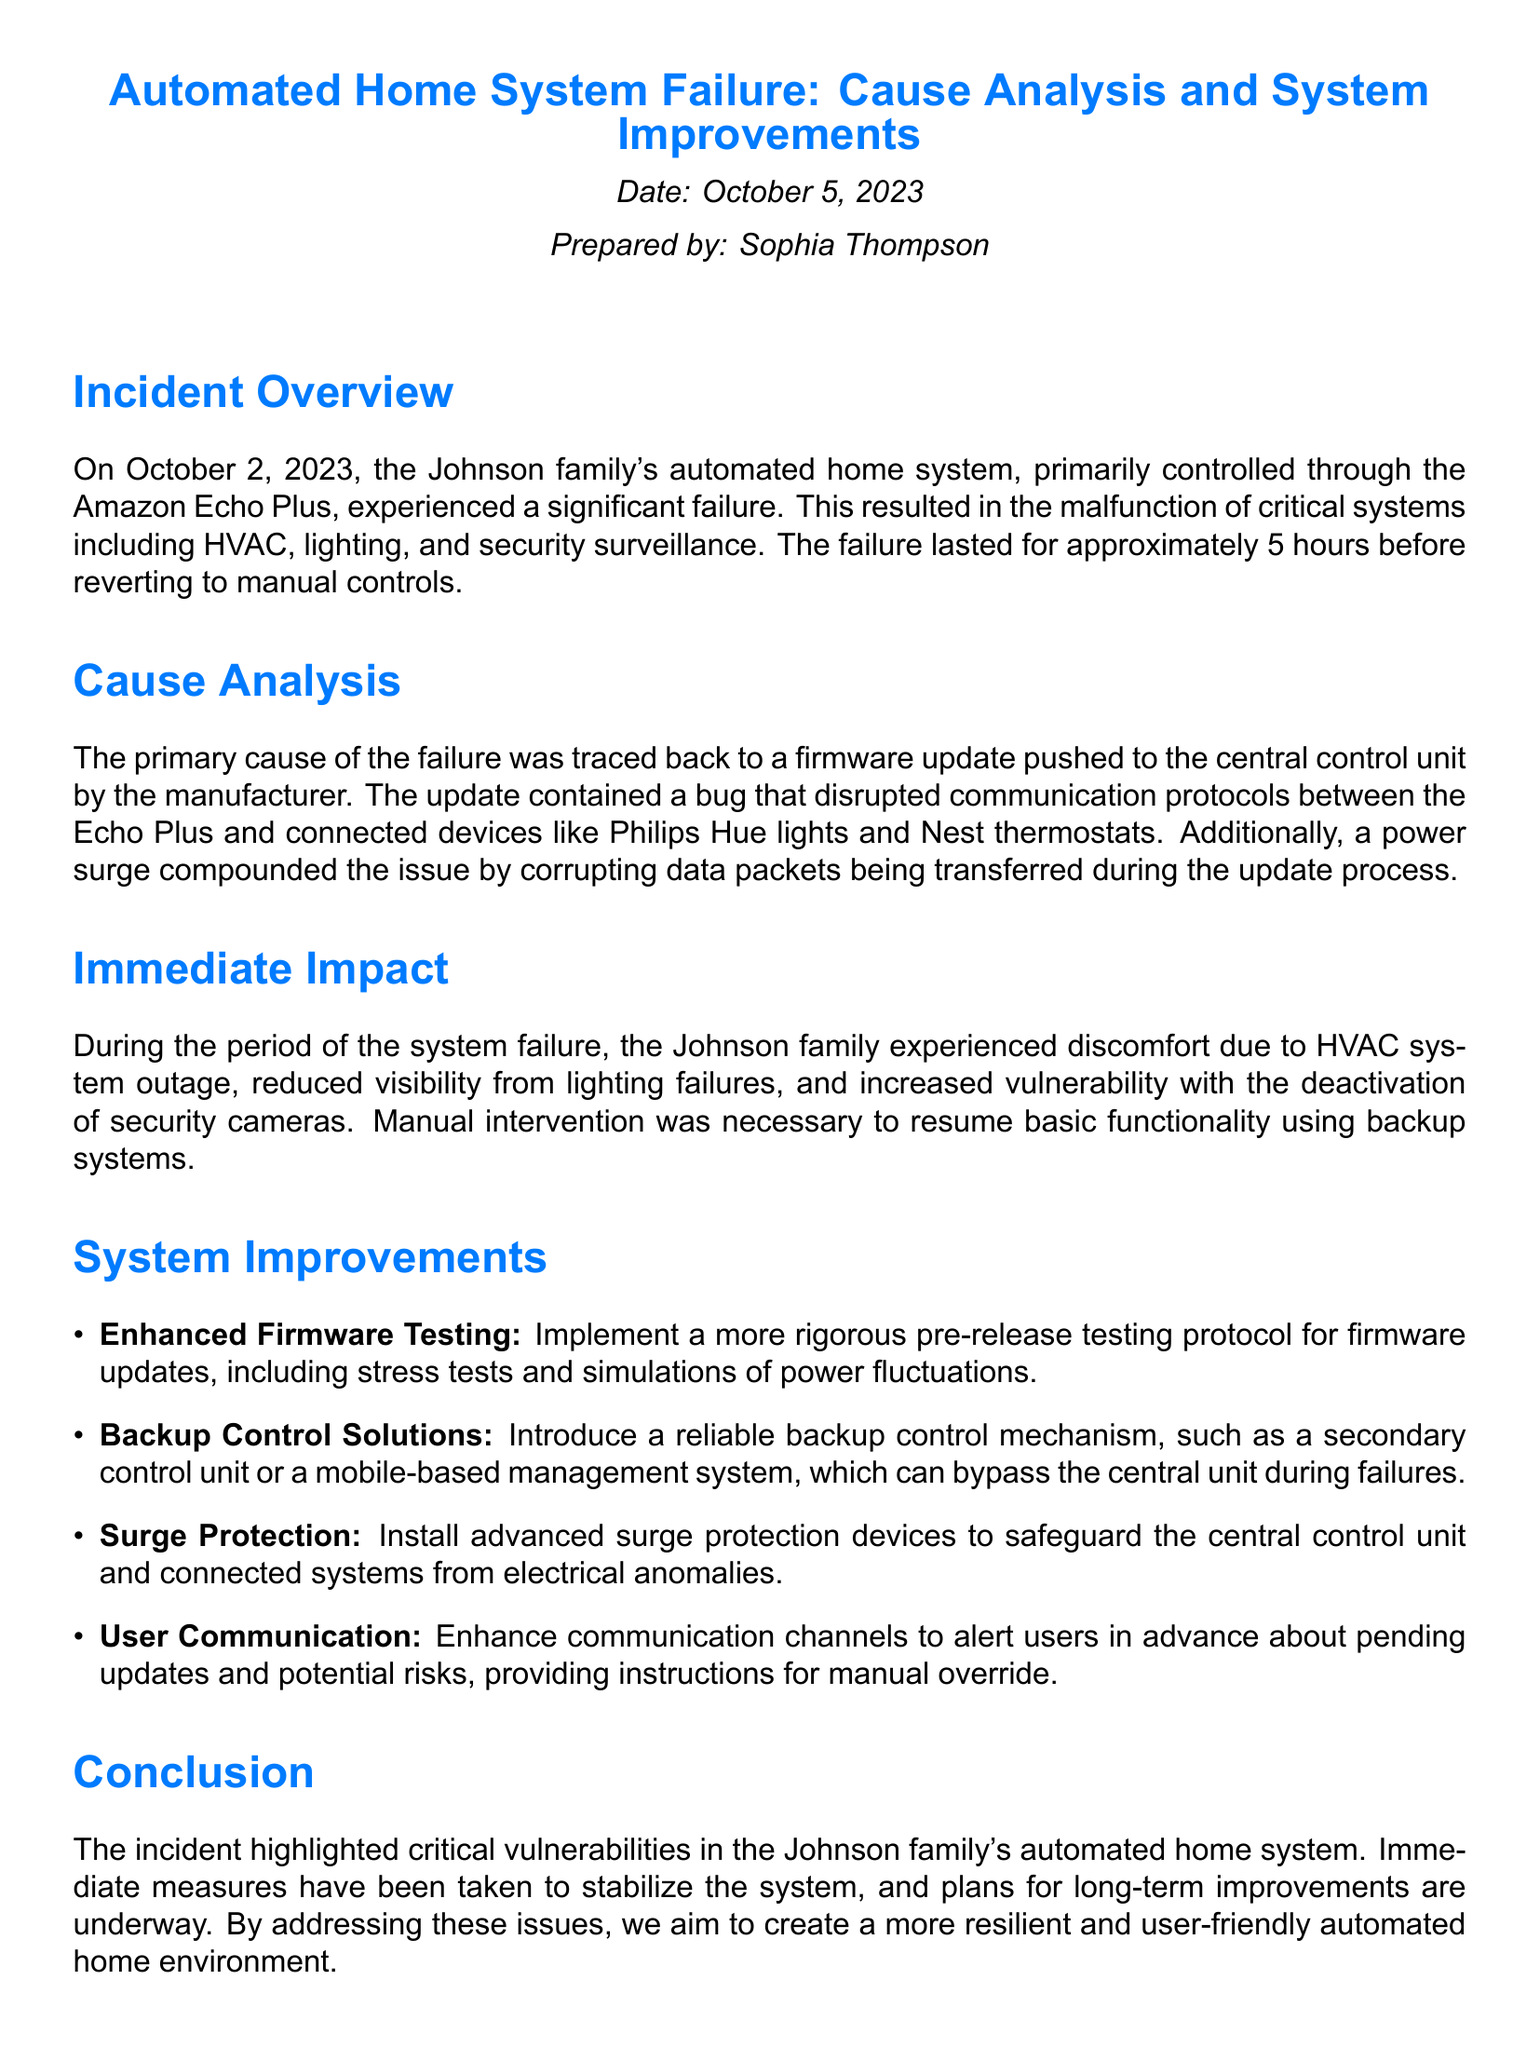What date did the incident occur? The incident occurred on October 2, 2023, as stated in the incident overview section.
Answer: October 2, 2023 Who prepared the incident report? The report was prepared by Sophia Thompson, mentioned in the document.
Answer: Sophia Thompson What was the primary cause of the failure? The primary cause of the failure was a firmware update that contained a bug.
Answer: Firmware update How long did the failure last? The duration of the failure lasted for approximately 5 hours according to the incident overview.
Answer: 5 hours What critical systems malfunctioned during the incident? The malfunctioning systems included HVAC, lighting, and security surveillance as explained in the overview.
Answer: HVAC, lighting, security surveillance What immediate impact did the family experience? The family experienced discomfort due to HVAC failure, reduced visibility from lighting failures, and increased vulnerability in security.
Answer: Discomfort What system improvement involves testing protocol? The improvement regarding testing protocol is enhanced firmware testing, detailed in the system improvements section.
Answer: Enhanced Firmware Testing What surge protection improvement is recommended? The document recommends the installation of advanced surge protection devices to safeguard systems.
Answer: Advanced surge protection devices What user communication enhancement is suggested? The suggested enhancement is to alert users in advance about pending updates.
Answer: Alert users in advance 